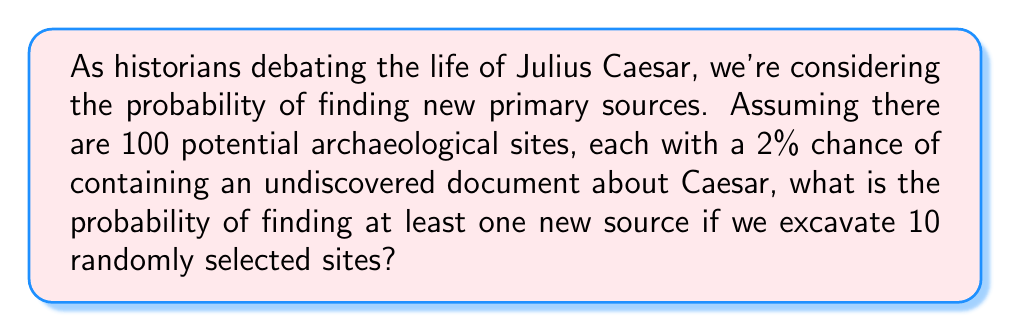What is the answer to this math problem? Let's approach this step-by-step:

1) First, we need to calculate the probability of not finding a new source at a single site. This is:

   $P(\text{no new source at one site}) = 1 - 0.02 = 0.98$

2) Now, we're excavating 10 sites. The probability of not finding a new source at any of these 10 sites is:

   $P(\text{no new source at all 10 sites}) = (0.98)^{10}$

3) Therefore, the probability of finding at least one new source is the complement of this:

   $P(\text{at least one new source}) = 1 - (0.98)^{10}$

4) Let's calculate this:

   $1 - (0.98)^{10} = 1 - 0.8179 = 0.1821$

5) Converting to a percentage:

   $0.1821 \times 100\% = 18.21\%$

Thus, there is approximately an 18.21% chance of finding at least one new primary source about Julius Caesar if we excavate 10 randomly selected sites.
Answer: 18.21% 